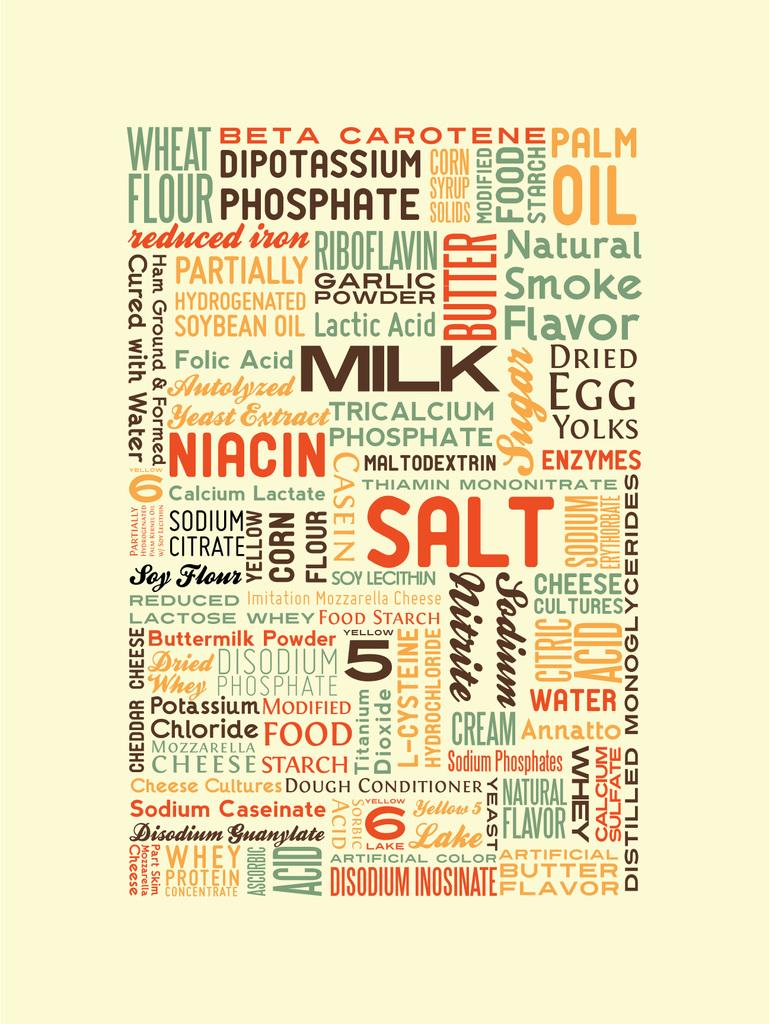What is the main subject in the middle of the image? There is a text in the middle of the image. How much does the quarter-sized dust particle weigh in the image? There is no dust particle, let alone a quarter-sized one, present in the image. 